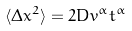<formula> <loc_0><loc_0><loc_500><loc_500>\langle \Delta x ^ { 2 } \rangle = 2 D v ^ { \alpha } t ^ { \alpha }</formula> 